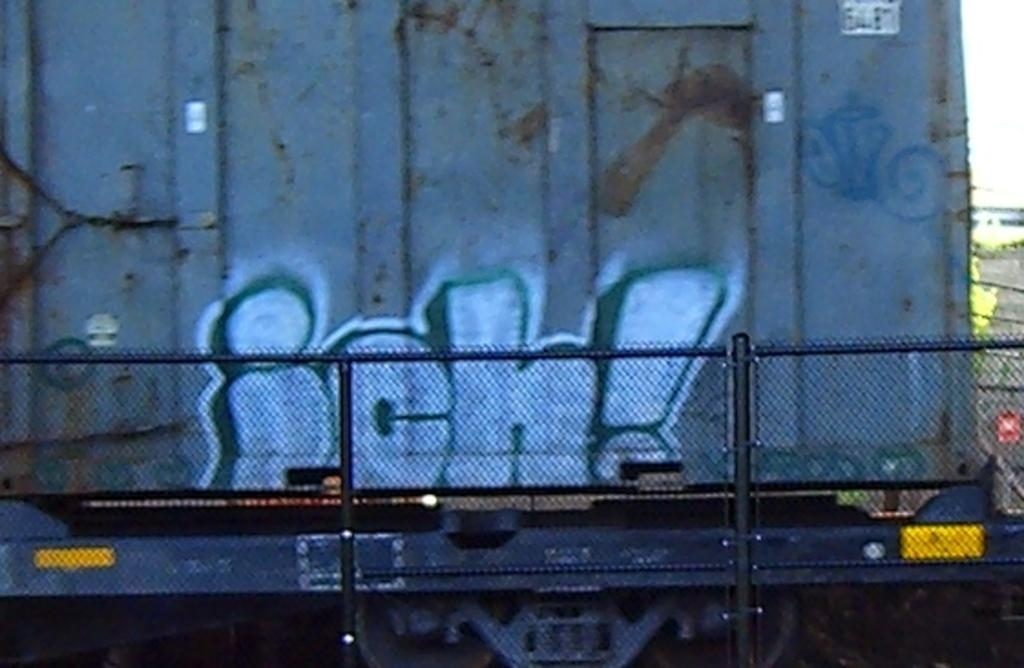<image>
Share a concise interpretation of the image provided. The back of the truck has "ich!" written on the back in blue and white spray paint. 